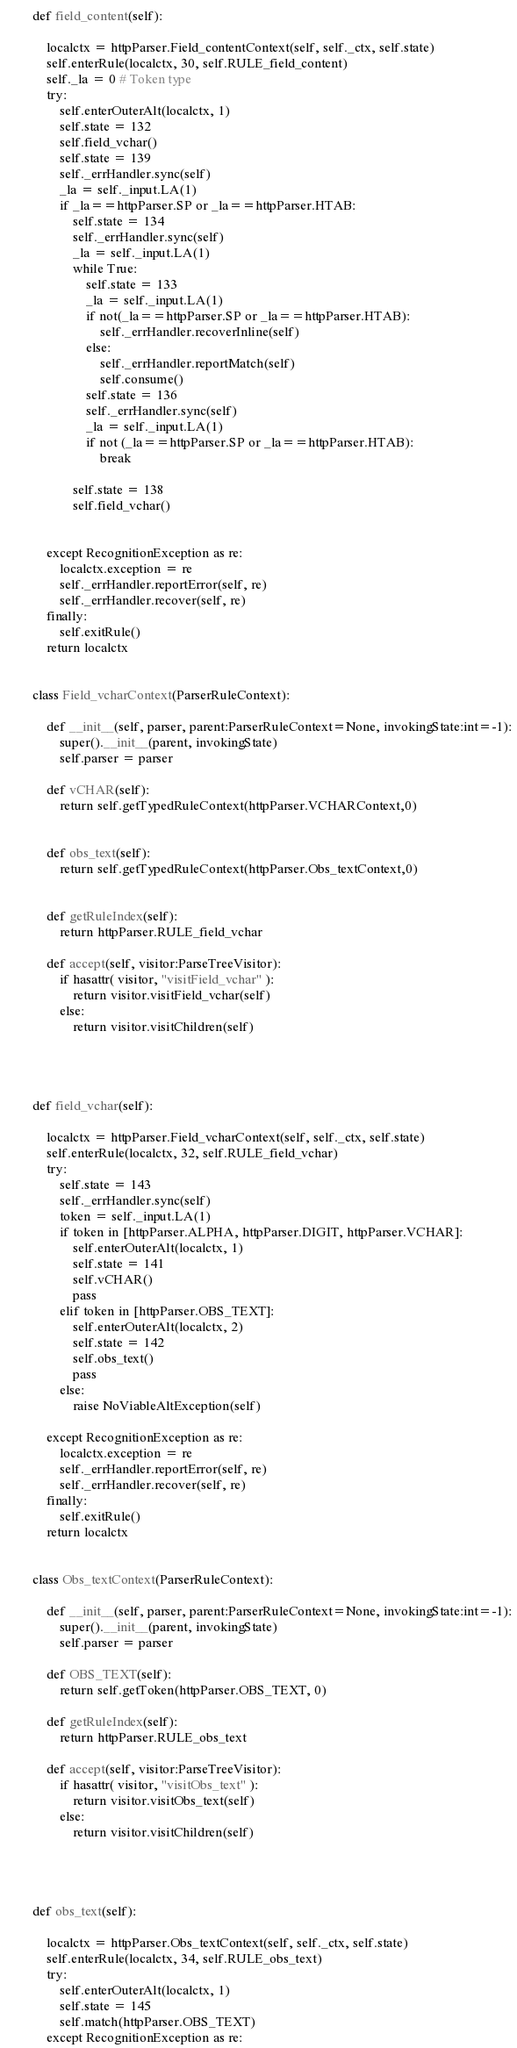Convert code to text. <code><loc_0><loc_0><loc_500><loc_500><_Python_>
    def field_content(self):

        localctx = httpParser.Field_contentContext(self, self._ctx, self.state)
        self.enterRule(localctx, 30, self.RULE_field_content)
        self._la = 0 # Token type
        try:
            self.enterOuterAlt(localctx, 1)
            self.state = 132
            self.field_vchar()
            self.state = 139
            self._errHandler.sync(self)
            _la = self._input.LA(1)
            if _la==httpParser.SP or _la==httpParser.HTAB:
                self.state = 134 
                self._errHandler.sync(self)
                _la = self._input.LA(1)
                while True:
                    self.state = 133
                    _la = self._input.LA(1)
                    if not(_la==httpParser.SP or _la==httpParser.HTAB):
                        self._errHandler.recoverInline(self)
                    else:
                        self._errHandler.reportMatch(self)
                        self.consume()
                    self.state = 136 
                    self._errHandler.sync(self)
                    _la = self._input.LA(1)
                    if not (_la==httpParser.SP or _la==httpParser.HTAB):
                        break

                self.state = 138
                self.field_vchar()


        except RecognitionException as re:
            localctx.exception = re
            self._errHandler.reportError(self, re)
            self._errHandler.recover(self, re)
        finally:
            self.exitRule()
        return localctx


    class Field_vcharContext(ParserRuleContext):

        def __init__(self, parser, parent:ParserRuleContext=None, invokingState:int=-1):
            super().__init__(parent, invokingState)
            self.parser = parser

        def vCHAR(self):
            return self.getTypedRuleContext(httpParser.VCHARContext,0)


        def obs_text(self):
            return self.getTypedRuleContext(httpParser.Obs_textContext,0)


        def getRuleIndex(self):
            return httpParser.RULE_field_vchar

        def accept(self, visitor:ParseTreeVisitor):
            if hasattr( visitor, "visitField_vchar" ):
                return visitor.visitField_vchar(self)
            else:
                return visitor.visitChildren(self)




    def field_vchar(self):

        localctx = httpParser.Field_vcharContext(self, self._ctx, self.state)
        self.enterRule(localctx, 32, self.RULE_field_vchar)
        try:
            self.state = 143
            self._errHandler.sync(self)
            token = self._input.LA(1)
            if token in [httpParser.ALPHA, httpParser.DIGIT, httpParser.VCHAR]:
                self.enterOuterAlt(localctx, 1)
                self.state = 141
                self.vCHAR()
                pass
            elif token in [httpParser.OBS_TEXT]:
                self.enterOuterAlt(localctx, 2)
                self.state = 142
                self.obs_text()
                pass
            else:
                raise NoViableAltException(self)

        except RecognitionException as re:
            localctx.exception = re
            self._errHandler.reportError(self, re)
            self._errHandler.recover(self, re)
        finally:
            self.exitRule()
        return localctx


    class Obs_textContext(ParserRuleContext):

        def __init__(self, parser, parent:ParserRuleContext=None, invokingState:int=-1):
            super().__init__(parent, invokingState)
            self.parser = parser

        def OBS_TEXT(self):
            return self.getToken(httpParser.OBS_TEXT, 0)

        def getRuleIndex(self):
            return httpParser.RULE_obs_text

        def accept(self, visitor:ParseTreeVisitor):
            if hasattr( visitor, "visitObs_text" ):
                return visitor.visitObs_text(self)
            else:
                return visitor.visitChildren(self)




    def obs_text(self):

        localctx = httpParser.Obs_textContext(self, self._ctx, self.state)
        self.enterRule(localctx, 34, self.RULE_obs_text)
        try:
            self.enterOuterAlt(localctx, 1)
            self.state = 145
            self.match(httpParser.OBS_TEXT)
        except RecognitionException as re:</code> 